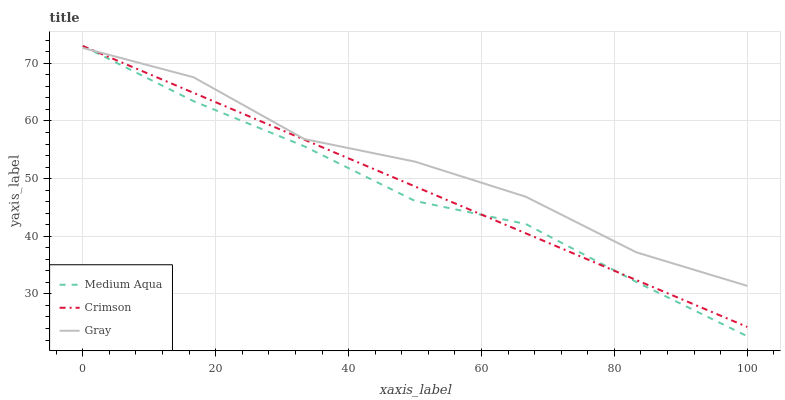Does Medium Aqua have the minimum area under the curve?
Answer yes or no. Yes. Does Gray have the maximum area under the curve?
Answer yes or no. Yes. Does Gray have the minimum area under the curve?
Answer yes or no. No. Does Medium Aqua have the maximum area under the curve?
Answer yes or no. No. Is Crimson the smoothest?
Answer yes or no. Yes. Is Gray the roughest?
Answer yes or no. Yes. Is Medium Aqua the smoothest?
Answer yes or no. No. Is Medium Aqua the roughest?
Answer yes or no. No. Does Medium Aqua have the lowest value?
Answer yes or no. Yes. Does Gray have the lowest value?
Answer yes or no. No. Does Medium Aqua have the highest value?
Answer yes or no. Yes. Does Gray have the highest value?
Answer yes or no. No. Does Medium Aqua intersect Crimson?
Answer yes or no. Yes. Is Medium Aqua less than Crimson?
Answer yes or no. No. Is Medium Aqua greater than Crimson?
Answer yes or no. No. 